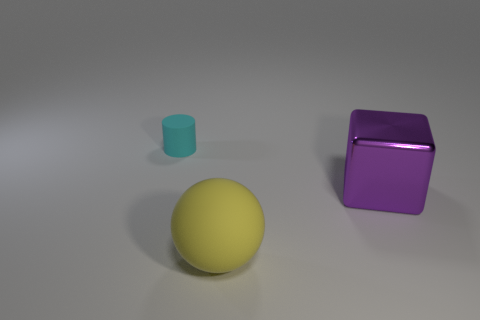Add 1 tiny cyan rubber objects. How many objects exist? 4 Subtract all balls. How many objects are left? 2 Subtract all cylinders. Subtract all tiny cyan rubber objects. How many objects are left? 1 Add 2 big metallic cubes. How many big metallic cubes are left? 3 Add 2 tiny red things. How many tiny red things exist? 2 Subtract 0 purple cylinders. How many objects are left? 3 Subtract 1 cubes. How many cubes are left? 0 Subtract all gray cubes. Subtract all yellow cylinders. How many cubes are left? 1 